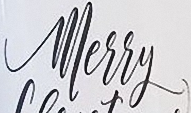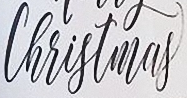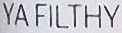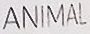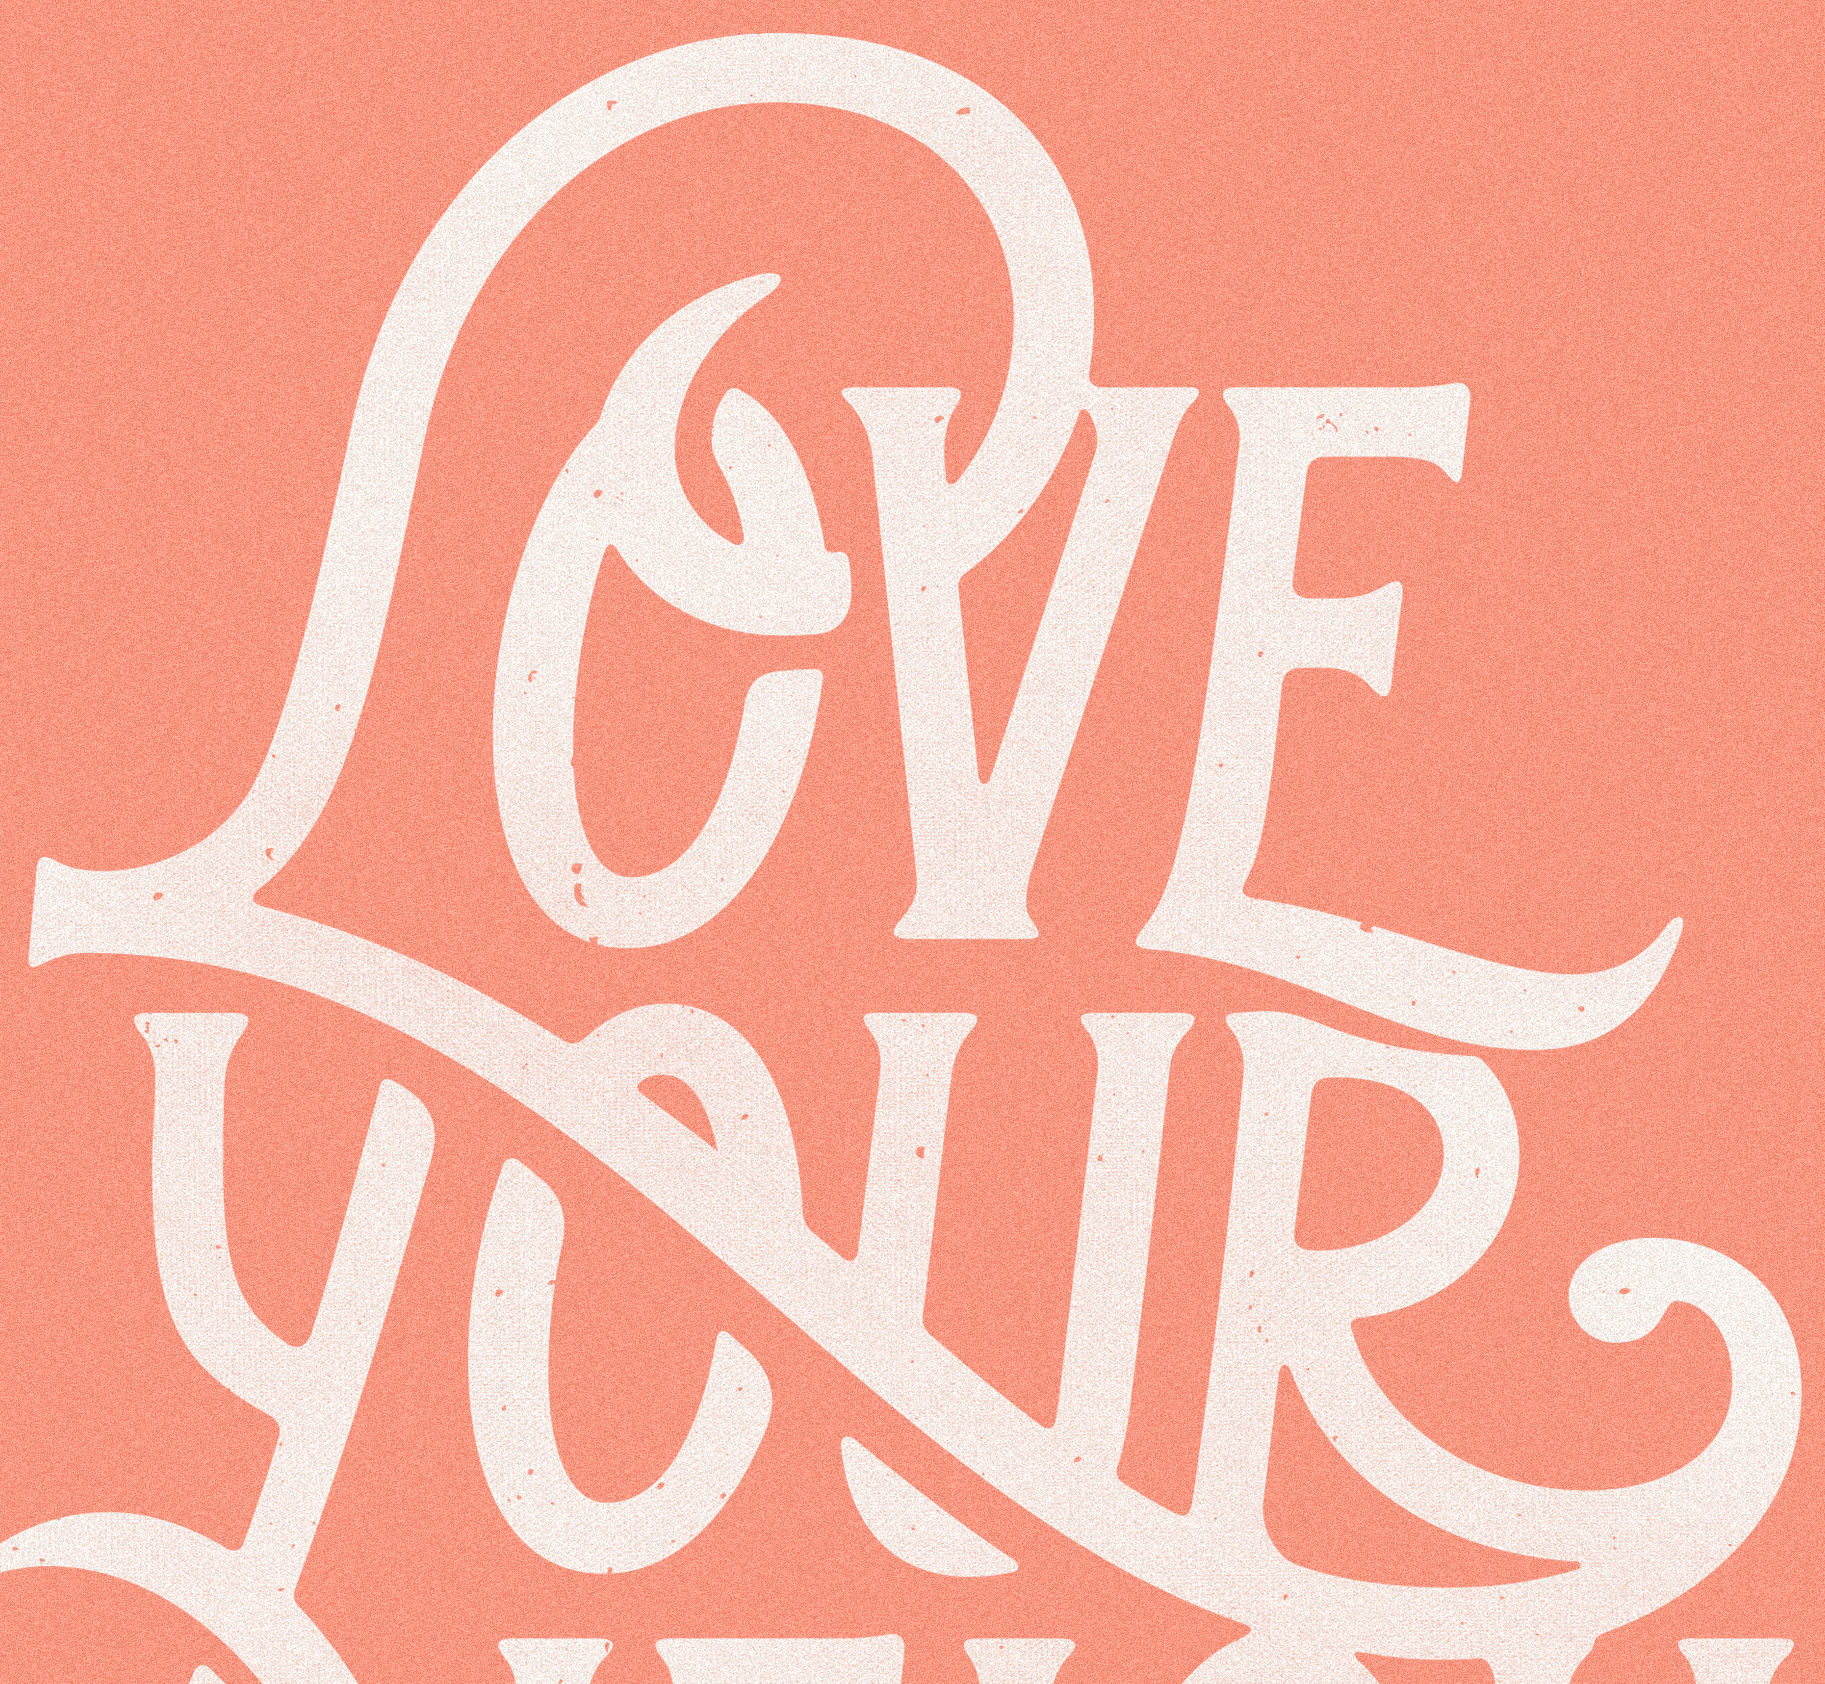Identify the words shown in these images in order, separated by a semicolon. Merry; Christmas; YAFILTHY; ANIMAL; LOVE 